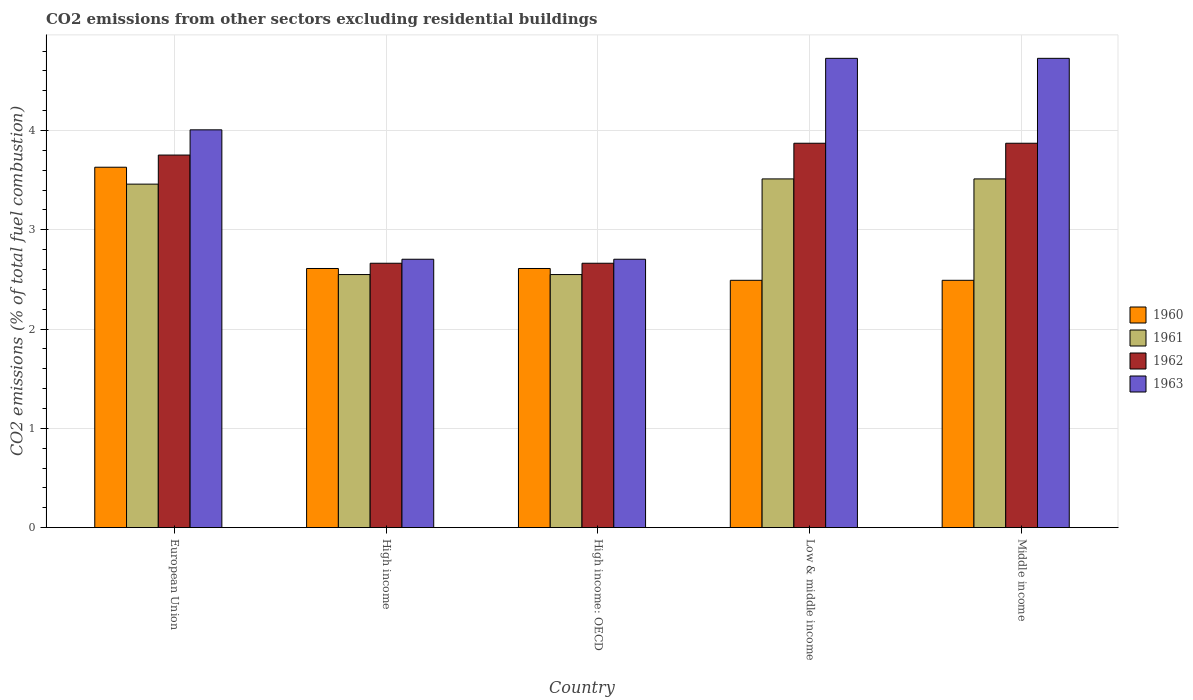How many different coloured bars are there?
Offer a terse response. 4. How many groups of bars are there?
Provide a short and direct response. 5. Are the number of bars per tick equal to the number of legend labels?
Offer a terse response. Yes. How many bars are there on the 3rd tick from the left?
Provide a succinct answer. 4. What is the total CO2 emitted in 1962 in European Union?
Provide a short and direct response. 3.75. Across all countries, what is the maximum total CO2 emitted in 1961?
Make the answer very short. 3.51. Across all countries, what is the minimum total CO2 emitted in 1961?
Provide a succinct answer. 2.55. What is the total total CO2 emitted in 1962 in the graph?
Offer a very short reply. 16.82. What is the difference between the total CO2 emitted in 1960 in High income and that in Low & middle income?
Ensure brevity in your answer.  0.12. What is the difference between the total CO2 emitted in 1961 in Middle income and the total CO2 emitted in 1960 in European Union?
Keep it short and to the point. -0.12. What is the average total CO2 emitted in 1961 per country?
Offer a terse response. 3.12. What is the difference between the total CO2 emitted of/in 1960 and total CO2 emitted of/in 1961 in Middle income?
Provide a short and direct response. -1.02. In how many countries, is the total CO2 emitted in 1960 greater than 1.2?
Offer a very short reply. 5. What is the ratio of the total CO2 emitted in 1961 in High income to that in Low & middle income?
Offer a very short reply. 0.73. Is the total CO2 emitted in 1961 in High income less than that in Low & middle income?
Your answer should be very brief. Yes. What is the difference between the highest and the second highest total CO2 emitted in 1963?
Provide a succinct answer. 0.72. What is the difference between the highest and the lowest total CO2 emitted in 1960?
Give a very brief answer. 1.14. What does the 2nd bar from the left in Middle income represents?
Offer a very short reply. 1961. What does the 4th bar from the right in European Union represents?
Provide a succinct answer. 1960. Is it the case that in every country, the sum of the total CO2 emitted in 1960 and total CO2 emitted in 1963 is greater than the total CO2 emitted in 1962?
Offer a very short reply. Yes. Are all the bars in the graph horizontal?
Ensure brevity in your answer.  No. How many countries are there in the graph?
Provide a succinct answer. 5. What is the difference between two consecutive major ticks on the Y-axis?
Make the answer very short. 1. Where does the legend appear in the graph?
Keep it short and to the point. Center right. How are the legend labels stacked?
Ensure brevity in your answer.  Vertical. What is the title of the graph?
Provide a short and direct response. CO2 emissions from other sectors excluding residential buildings. Does "1967" appear as one of the legend labels in the graph?
Keep it short and to the point. No. What is the label or title of the X-axis?
Your response must be concise. Country. What is the label or title of the Y-axis?
Ensure brevity in your answer.  CO2 emissions (% of total fuel combustion). What is the CO2 emissions (% of total fuel combustion) of 1960 in European Union?
Offer a very short reply. 3.63. What is the CO2 emissions (% of total fuel combustion) of 1961 in European Union?
Give a very brief answer. 3.46. What is the CO2 emissions (% of total fuel combustion) in 1962 in European Union?
Offer a very short reply. 3.75. What is the CO2 emissions (% of total fuel combustion) of 1963 in European Union?
Make the answer very short. 4.01. What is the CO2 emissions (% of total fuel combustion) in 1960 in High income?
Your response must be concise. 2.61. What is the CO2 emissions (% of total fuel combustion) in 1961 in High income?
Offer a very short reply. 2.55. What is the CO2 emissions (% of total fuel combustion) in 1962 in High income?
Your response must be concise. 2.66. What is the CO2 emissions (% of total fuel combustion) of 1963 in High income?
Your response must be concise. 2.7. What is the CO2 emissions (% of total fuel combustion) of 1960 in High income: OECD?
Provide a short and direct response. 2.61. What is the CO2 emissions (% of total fuel combustion) of 1961 in High income: OECD?
Provide a succinct answer. 2.55. What is the CO2 emissions (% of total fuel combustion) of 1962 in High income: OECD?
Give a very brief answer. 2.66. What is the CO2 emissions (% of total fuel combustion) in 1963 in High income: OECD?
Provide a short and direct response. 2.7. What is the CO2 emissions (% of total fuel combustion) of 1960 in Low & middle income?
Your response must be concise. 2.49. What is the CO2 emissions (% of total fuel combustion) in 1961 in Low & middle income?
Provide a succinct answer. 3.51. What is the CO2 emissions (% of total fuel combustion) of 1962 in Low & middle income?
Your answer should be compact. 3.87. What is the CO2 emissions (% of total fuel combustion) in 1963 in Low & middle income?
Give a very brief answer. 4.73. What is the CO2 emissions (% of total fuel combustion) in 1960 in Middle income?
Provide a succinct answer. 2.49. What is the CO2 emissions (% of total fuel combustion) in 1961 in Middle income?
Keep it short and to the point. 3.51. What is the CO2 emissions (% of total fuel combustion) of 1962 in Middle income?
Give a very brief answer. 3.87. What is the CO2 emissions (% of total fuel combustion) in 1963 in Middle income?
Give a very brief answer. 4.73. Across all countries, what is the maximum CO2 emissions (% of total fuel combustion) of 1960?
Your response must be concise. 3.63. Across all countries, what is the maximum CO2 emissions (% of total fuel combustion) of 1961?
Provide a succinct answer. 3.51. Across all countries, what is the maximum CO2 emissions (% of total fuel combustion) in 1962?
Provide a short and direct response. 3.87. Across all countries, what is the maximum CO2 emissions (% of total fuel combustion) in 1963?
Your response must be concise. 4.73. Across all countries, what is the minimum CO2 emissions (% of total fuel combustion) in 1960?
Offer a very short reply. 2.49. Across all countries, what is the minimum CO2 emissions (% of total fuel combustion) of 1961?
Your answer should be very brief. 2.55. Across all countries, what is the minimum CO2 emissions (% of total fuel combustion) in 1962?
Provide a succinct answer. 2.66. Across all countries, what is the minimum CO2 emissions (% of total fuel combustion) of 1963?
Offer a very short reply. 2.7. What is the total CO2 emissions (% of total fuel combustion) of 1960 in the graph?
Your response must be concise. 13.83. What is the total CO2 emissions (% of total fuel combustion) in 1961 in the graph?
Provide a succinct answer. 15.58. What is the total CO2 emissions (% of total fuel combustion) in 1962 in the graph?
Your response must be concise. 16.82. What is the total CO2 emissions (% of total fuel combustion) of 1963 in the graph?
Ensure brevity in your answer.  18.86. What is the difference between the CO2 emissions (% of total fuel combustion) in 1960 in European Union and that in High income?
Give a very brief answer. 1.02. What is the difference between the CO2 emissions (% of total fuel combustion) of 1961 in European Union and that in High income?
Offer a terse response. 0.91. What is the difference between the CO2 emissions (% of total fuel combustion) in 1962 in European Union and that in High income?
Provide a short and direct response. 1.09. What is the difference between the CO2 emissions (% of total fuel combustion) in 1963 in European Union and that in High income?
Offer a terse response. 1.3. What is the difference between the CO2 emissions (% of total fuel combustion) of 1960 in European Union and that in High income: OECD?
Make the answer very short. 1.02. What is the difference between the CO2 emissions (% of total fuel combustion) of 1961 in European Union and that in High income: OECD?
Offer a terse response. 0.91. What is the difference between the CO2 emissions (% of total fuel combustion) in 1962 in European Union and that in High income: OECD?
Your answer should be compact. 1.09. What is the difference between the CO2 emissions (% of total fuel combustion) of 1963 in European Union and that in High income: OECD?
Give a very brief answer. 1.3. What is the difference between the CO2 emissions (% of total fuel combustion) in 1960 in European Union and that in Low & middle income?
Your answer should be compact. 1.14. What is the difference between the CO2 emissions (% of total fuel combustion) in 1961 in European Union and that in Low & middle income?
Ensure brevity in your answer.  -0.05. What is the difference between the CO2 emissions (% of total fuel combustion) of 1962 in European Union and that in Low & middle income?
Offer a terse response. -0.12. What is the difference between the CO2 emissions (% of total fuel combustion) in 1963 in European Union and that in Low & middle income?
Provide a short and direct response. -0.72. What is the difference between the CO2 emissions (% of total fuel combustion) of 1960 in European Union and that in Middle income?
Your response must be concise. 1.14. What is the difference between the CO2 emissions (% of total fuel combustion) of 1961 in European Union and that in Middle income?
Provide a succinct answer. -0.05. What is the difference between the CO2 emissions (% of total fuel combustion) of 1962 in European Union and that in Middle income?
Your answer should be compact. -0.12. What is the difference between the CO2 emissions (% of total fuel combustion) in 1963 in European Union and that in Middle income?
Give a very brief answer. -0.72. What is the difference between the CO2 emissions (% of total fuel combustion) in 1960 in High income and that in High income: OECD?
Offer a terse response. 0. What is the difference between the CO2 emissions (% of total fuel combustion) of 1963 in High income and that in High income: OECD?
Offer a very short reply. 0. What is the difference between the CO2 emissions (% of total fuel combustion) of 1960 in High income and that in Low & middle income?
Keep it short and to the point. 0.12. What is the difference between the CO2 emissions (% of total fuel combustion) in 1961 in High income and that in Low & middle income?
Offer a very short reply. -0.96. What is the difference between the CO2 emissions (% of total fuel combustion) of 1962 in High income and that in Low & middle income?
Make the answer very short. -1.21. What is the difference between the CO2 emissions (% of total fuel combustion) of 1963 in High income and that in Low & middle income?
Make the answer very short. -2.02. What is the difference between the CO2 emissions (% of total fuel combustion) in 1960 in High income and that in Middle income?
Ensure brevity in your answer.  0.12. What is the difference between the CO2 emissions (% of total fuel combustion) in 1961 in High income and that in Middle income?
Make the answer very short. -0.96. What is the difference between the CO2 emissions (% of total fuel combustion) of 1962 in High income and that in Middle income?
Your answer should be compact. -1.21. What is the difference between the CO2 emissions (% of total fuel combustion) in 1963 in High income and that in Middle income?
Offer a very short reply. -2.02. What is the difference between the CO2 emissions (% of total fuel combustion) in 1960 in High income: OECD and that in Low & middle income?
Give a very brief answer. 0.12. What is the difference between the CO2 emissions (% of total fuel combustion) in 1961 in High income: OECD and that in Low & middle income?
Your answer should be compact. -0.96. What is the difference between the CO2 emissions (% of total fuel combustion) of 1962 in High income: OECD and that in Low & middle income?
Make the answer very short. -1.21. What is the difference between the CO2 emissions (% of total fuel combustion) of 1963 in High income: OECD and that in Low & middle income?
Offer a very short reply. -2.02. What is the difference between the CO2 emissions (% of total fuel combustion) of 1960 in High income: OECD and that in Middle income?
Provide a short and direct response. 0.12. What is the difference between the CO2 emissions (% of total fuel combustion) in 1961 in High income: OECD and that in Middle income?
Offer a very short reply. -0.96. What is the difference between the CO2 emissions (% of total fuel combustion) of 1962 in High income: OECD and that in Middle income?
Provide a short and direct response. -1.21. What is the difference between the CO2 emissions (% of total fuel combustion) of 1963 in High income: OECD and that in Middle income?
Keep it short and to the point. -2.02. What is the difference between the CO2 emissions (% of total fuel combustion) in 1960 in Low & middle income and that in Middle income?
Ensure brevity in your answer.  0. What is the difference between the CO2 emissions (% of total fuel combustion) of 1963 in Low & middle income and that in Middle income?
Provide a succinct answer. 0. What is the difference between the CO2 emissions (% of total fuel combustion) of 1960 in European Union and the CO2 emissions (% of total fuel combustion) of 1961 in High income?
Give a very brief answer. 1.08. What is the difference between the CO2 emissions (% of total fuel combustion) in 1960 in European Union and the CO2 emissions (% of total fuel combustion) in 1962 in High income?
Offer a terse response. 0.97. What is the difference between the CO2 emissions (% of total fuel combustion) of 1960 in European Union and the CO2 emissions (% of total fuel combustion) of 1963 in High income?
Offer a very short reply. 0.93. What is the difference between the CO2 emissions (% of total fuel combustion) in 1961 in European Union and the CO2 emissions (% of total fuel combustion) in 1962 in High income?
Offer a very short reply. 0.8. What is the difference between the CO2 emissions (% of total fuel combustion) of 1961 in European Union and the CO2 emissions (% of total fuel combustion) of 1963 in High income?
Ensure brevity in your answer.  0.76. What is the difference between the CO2 emissions (% of total fuel combustion) in 1962 in European Union and the CO2 emissions (% of total fuel combustion) in 1963 in High income?
Ensure brevity in your answer.  1.05. What is the difference between the CO2 emissions (% of total fuel combustion) of 1960 in European Union and the CO2 emissions (% of total fuel combustion) of 1961 in High income: OECD?
Make the answer very short. 1.08. What is the difference between the CO2 emissions (% of total fuel combustion) in 1960 in European Union and the CO2 emissions (% of total fuel combustion) in 1962 in High income: OECD?
Your response must be concise. 0.97. What is the difference between the CO2 emissions (% of total fuel combustion) of 1960 in European Union and the CO2 emissions (% of total fuel combustion) of 1963 in High income: OECD?
Ensure brevity in your answer.  0.93. What is the difference between the CO2 emissions (% of total fuel combustion) of 1961 in European Union and the CO2 emissions (% of total fuel combustion) of 1962 in High income: OECD?
Provide a short and direct response. 0.8. What is the difference between the CO2 emissions (% of total fuel combustion) of 1961 in European Union and the CO2 emissions (% of total fuel combustion) of 1963 in High income: OECD?
Your response must be concise. 0.76. What is the difference between the CO2 emissions (% of total fuel combustion) in 1962 in European Union and the CO2 emissions (% of total fuel combustion) in 1963 in High income: OECD?
Your answer should be compact. 1.05. What is the difference between the CO2 emissions (% of total fuel combustion) in 1960 in European Union and the CO2 emissions (% of total fuel combustion) in 1961 in Low & middle income?
Make the answer very short. 0.12. What is the difference between the CO2 emissions (% of total fuel combustion) of 1960 in European Union and the CO2 emissions (% of total fuel combustion) of 1962 in Low & middle income?
Your answer should be very brief. -0.24. What is the difference between the CO2 emissions (% of total fuel combustion) of 1960 in European Union and the CO2 emissions (% of total fuel combustion) of 1963 in Low & middle income?
Your response must be concise. -1.1. What is the difference between the CO2 emissions (% of total fuel combustion) in 1961 in European Union and the CO2 emissions (% of total fuel combustion) in 1962 in Low & middle income?
Offer a terse response. -0.41. What is the difference between the CO2 emissions (% of total fuel combustion) of 1961 in European Union and the CO2 emissions (% of total fuel combustion) of 1963 in Low & middle income?
Give a very brief answer. -1.27. What is the difference between the CO2 emissions (% of total fuel combustion) in 1962 in European Union and the CO2 emissions (% of total fuel combustion) in 1963 in Low & middle income?
Your answer should be compact. -0.97. What is the difference between the CO2 emissions (% of total fuel combustion) in 1960 in European Union and the CO2 emissions (% of total fuel combustion) in 1961 in Middle income?
Give a very brief answer. 0.12. What is the difference between the CO2 emissions (% of total fuel combustion) in 1960 in European Union and the CO2 emissions (% of total fuel combustion) in 1962 in Middle income?
Your response must be concise. -0.24. What is the difference between the CO2 emissions (% of total fuel combustion) of 1960 in European Union and the CO2 emissions (% of total fuel combustion) of 1963 in Middle income?
Make the answer very short. -1.1. What is the difference between the CO2 emissions (% of total fuel combustion) of 1961 in European Union and the CO2 emissions (% of total fuel combustion) of 1962 in Middle income?
Make the answer very short. -0.41. What is the difference between the CO2 emissions (% of total fuel combustion) of 1961 in European Union and the CO2 emissions (% of total fuel combustion) of 1963 in Middle income?
Keep it short and to the point. -1.27. What is the difference between the CO2 emissions (% of total fuel combustion) of 1962 in European Union and the CO2 emissions (% of total fuel combustion) of 1963 in Middle income?
Keep it short and to the point. -0.97. What is the difference between the CO2 emissions (% of total fuel combustion) of 1960 in High income and the CO2 emissions (% of total fuel combustion) of 1961 in High income: OECD?
Offer a very short reply. 0.06. What is the difference between the CO2 emissions (% of total fuel combustion) in 1960 in High income and the CO2 emissions (% of total fuel combustion) in 1962 in High income: OECD?
Give a very brief answer. -0.05. What is the difference between the CO2 emissions (% of total fuel combustion) in 1960 in High income and the CO2 emissions (% of total fuel combustion) in 1963 in High income: OECD?
Make the answer very short. -0.09. What is the difference between the CO2 emissions (% of total fuel combustion) in 1961 in High income and the CO2 emissions (% of total fuel combustion) in 1962 in High income: OECD?
Make the answer very short. -0.11. What is the difference between the CO2 emissions (% of total fuel combustion) in 1961 in High income and the CO2 emissions (% of total fuel combustion) in 1963 in High income: OECD?
Offer a terse response. -0.15. What is the difference between the CO2 emissions (% of total fuel combustion) of 1962 in High income and the CO2 emissions (% of total fuel combustion) of 1963 in High income: OECD?
Give a very brief answer. -0.04. What is the difference between the CO2 emissions (% of total fuel combustion) in 1960 in High income and the CO2 emissions (% of total fuel combustion) in 1961 in Low & middle income?
Your answer should be very brief. -0.9. What is the difference between the CO2 emissions (% of total fuel combustion) of 1960 in High income and the CO2 emissions (% of total fuel combustion) of 1962 in Low & middle income?
Provide a succinct answer. -1.26. What is the difference between the CO2 emissions (% of total fuel combustion) of 1960 in High income and the CO2 emissions (% of total fuel combustion) of 1963 in Low & middle income?
Your answer should be compact. -2.12. What is the difference between the CO2 emissions (% of total fuel combustion) in 1961 in High income and the CO2 emissions (% of total fuel combustion) in 1962 in Low & middle income?
Make the answer very short. -1.32. What is the difference between the CO2 emissions (% of total fuel combustion) in 1961 in High income and the CO2 emissions (% of total fuel combustion) in 1963 in Low & middle income?
Your answer should be very brief. -2.18. What is the difference between the CO2 emissions (% of total fuel combustion) of 1962 in High income and the CO2 emissions (% of total fuel combustion) of 1963 in Low & middle income?
Ensure brevity in your answer.  -2.06. What is the difference between the CO2 emissions (% of total fuel combustion) in 1960 in High income and the CO2 emissions (% of total fuel combustion) in 1961 in Middle income?
Ensure brevity in your answer.  -0.9. What is the difference between the CO2 emissions (% of total fuel combustion) in 1960 in High income and the CO2 emissions (% of total fuel combustion) in 1962 in Middle income?
Offer a terse response. -1.26. What is the difference between the CO2 emissions (% of total fuel combustion) in 1960 in High income and the CO2 emissions (% of total fuel combustion) in 1963 in Middle income?
Keep it short and to the point. -2.12. What is the difference between the CO2 emissions (% of total fuel combustion) in 1961 in High income and the CO2 emissions (% of total fuel combustion) in 1962 in Middle income?
Your answer should be very brief. -1.32. What is the difference between the CO2 emissions (% of total fuel combustion) in 1961 in High income and the CO2 emissions (% of total fuel combustion) in 1963 in Middle income?
Make the answer very short. -2.18. What is the difference between the CO2 emissions (% of total fuel combustion) of 1962 in High income and the CO2 emissions (% of total fuel combustion) of 1963 in Middle income?
Give a very brief answer. -2.06. What is the difference between the CO2 emissions (% of total fuel combustion) in 1960 in High income: OECD and the CO2 emissions (% of total fuel combustion) in 1961 in Low & middle income?
Your answer should be compact. -0.9. What is the difference between the CO2 emissions (% of total fuel combustion) in 1960 in High income: OECD and the CO2 emissions (% of total fuel combustion) in 1962 in Low & middle income?
Your response must be concise. -1.26. What is the difference between the CO2 emissions (% of total fuel combustion) in 1960 in High income: OECD and the CO2 emissions (% of total fuel combustion) in 1963 in Low & middle income?
Provide a succinct answer. -2.12. What is the difference between the CO2 emissions (% of total fuel combustion) of 1961 in High income: OECD and the CO2 emissions (% of total fuel combustion) of 1962 in Low & middle income?
Ensure brevity in your answer.  -1.32. What is the difference between the CO2 emissions (% of total fuel combustion) in 1961 in High income: OECD and the CO2 emissions (% of total fuel combustion) in 1963 in Low & middle income?
Ensure brevity in your answer.  -2.18. What is the difference between the CO2 emissions (% of total fuel combustion) in 1962 in High income: OECD and the CO2 emissions (% of total fuel combustion) in 1963 in Low & middle income?
Ensure brevity in your answer.  -2.06. What is the difference between the CO2 emissions (% of total fuel combustion) in 1960 in High income: OECD and the CO2 emissions (% of total fuel combustion) in 1961 in Middle income?
Offer a very short reply. -0.9. What is the difference between the CO2 emissions (% of total fuel combustion) in 1960 in High income: OECD and the CO2 emissions (% of total fuel combustion) in 1962 in Middle income?
Keep it short and to the point. -1.26. What is the difference between the CO2 emissions (% of total fuel combustion) in 1960 in High income: OECD and the CO2 emissions (% of total fuel combustion) in 1963 in Middle income?
Offer a terse response. -2.12. What is the difference between the CO2 emissions (% of total fuel combustion) of 1961 in High income: OECD and the CO2 emissions (% of total fuel combustion) of 1962 in Middle income?
Your answer should be compact. -1.32. What is the difference between the CO2 emissions (% of total fuel combustion) of 1961 in High income: OECD and the CO2 emissions (% of total fuel combustion) of 1963 in Middle income?
Your answer should be very brief. -2.18. What is the difference between the CO2 emissions (% of total fuel combustion) in 1962 in High income: OECD and the CO2 emissions (% of total fuel combustion) in 1963 in Middle income?
Your answer should be very brief. -2.06. What is the difference between the CO2 emissions (% of total fuel combustion) of 1960 in Low & middle income and the CO2 emissions (% of total fuel combustion) of 1961 in Middle income?
Your answer should be very brief. -1.02. What is the difference between the CO2 emissions (% of total fuel combustion) of 1960 in Low & middle income and the CO2 emissions (% of total fuel combustion) of 1962 in Middle income?
Offer a very short reply. -1.38. What is the difference between the CO2 emissions (% of total fuel combustion) of 1960 in Low & middle income and the CO2 emissions (% of total fuel combustion) of 1963 in Middle income?
Offer a terse response. -2.24. What is the difference between the CO2 emissions (% of total fuel combustion) in 1961 in Low & middle income and the CO2 emissions (% of total fuel combustion) in 1962 in Middle income?
Your response must be concise. -0.36. What is the difference between the CO2 emissions (% of total fuel combustion) in 1961 in Low & middle income and the CO2 emissions (% of total fuel combustion) in 1963 in Middle income?
Your answer should be compact. -1.21. What is the difference between the CO2 emissions (% of total fuel combustion) in 1962 in Low & middle income and the CO2 emissions (% of total fuel combustion) in 1963 in Middle income?
Make the answer very short. -0.85. What is the average CO2 emissions (% of total fuel combustion) of 1960 per country?
Keep it short and to the point. 2.77. What is the average CO2 emissions (% of total fuel combustion) of 1961 per country?
Your answer should be compact. 3.12. What is the average CO2 emissions (% of total fuel combustion) in 1962 per country?
Provide a short and direct response. 3.36. What is the average CO2 emissions (% of total fuel combustion) in 1963 per country?
Offer a very short reply. 3.77. What is the difference between the CO2 emissions (% of total fuel combustion) in 1960 and CO2 emissions (% of total fuel combustion) in 1961 in European Union?
Your response must be concise. 0.17. What is the difference between the CO2 emissions (% of total fuel combustion) in 1960 and CO2 emissions (% of total fuel combustion) in 1962 in European Union?
Keep it short and to the point. -0.12. What is the difference between the CO2 emissions (% of total fuel combustion) of 1960 and CO2 emissions (% of total fuel combustion) of 1963 in European Union?
Your answer should be compact. -0.38. What is the difference between the CO2 emissions (% of total fuel combustion) in 1961 and CO2 emissions (% of total fuel combustion) in 1962 in European Union?
Make the answer very short. -0.29. What is the difference between the CO2 emissions (% of total fuel combustion) in 1961 and CO2 emissions (% of total fuel combustion) in 1963 in European Union?
Offer a very short reply. -0.55. What is the difference between the CO2 emissions (% of total fuel combustion) of 1962 and CO2 emissions (% of total fuel combustion) of 1963 in European Union?
Provide a short and direct response. -0.25. What is the difference between the CO2 emissions (% of total fuel combustion) in 1960 and CO2 emissions (% of total fuel combustion) in 1961 in High income?
Keep it short and to the point. 0.06. What is the difference between the CO2 emissions (% of total fuel combustion) of 1960 and CO2 emissions (% of total fuel combustion) of 1962 in High income?
Keep it short and to the point. -0.05. What is the difference between the CO2 emissions (% of total fuel combustion) of 1960 and CO2 emissions (% of total fuel combustion) of 1963 in High income?
Ensure brevity in your answer.  -0.09. What is the difference between the CO2 emissions (% of total fuel combustion) of 1961 and CO2 emissions (% of total fuel combustion) of 1962 in High income?
Provide a succinct answer. -0.11. What is the difference between the CO2 emissions (% of total fuel combustion) of 1961 and CO2 emissions (% of total fuel combustion) of 1963 in High income?
Your answer should be compact. -0.15. What is the difference between the CO2 emissions (% of total fuel combustion) in 1962 and CO2 emissions (% of total fuel combustion) in 1963 in High income?
Your response must be concise. -0.04. What is the difference between the CO2 emissions (% of total fuel combustion) in 1960 and CO2 emissions (% of total fuel combustion) in 1961 in High income: OECD?
Keep it short and to the point. 0.06. What is the difference between the CO2 emissions (% of total fuel combustion) in 1960 and CO2 emissions (% of total fuel combustion) in 1962 in High income: OECD?
Your answer should be very brief. -0.05. What is the difference between the CO2 emissions (% of total fuel combustion) of 1960 and CO2 emissions (% of total fuel combustion) of 1963 in High income: OECD?
Keep it short and to the point. -0.09. What is the difference between the CO2 emissions (% of total fuel combustion) in 1961 and CO2 emissions (% of total fuel combustion) in 1962 in High income: OECD?
Ensure brevity in your answer.  -0.11. What is the difference between the CO2 emissions (% of total fuel combustion) of 1961 and CO2 emissions (% of total fuel combustion) of 1963 in High income: OECD?
Make the answer very short. -0.15. What is the difference between the CO2 emissions (% of total fuel combustion) of 1962 and CO2 emissions (% of total fuel combustion) of 1963 in High income: OECD?
Your response must be concise. -0.04. What is the difference between the CO2 emissions (% of total fuel combustion) in 1960 and CO2 emissions (% of total fuel combustion) in 1961 in Low & middle income?
Provide a short and direct response. -1.02. What is the difference between the CO2 emissions (% of total fuel combustion) in 1960 and CO2 emissions (% of total fuel combustion) in 1962 in Low & middle income?
Your answer should be very brief. -1.38. What is the difference between the CO2 emissions (% of total fuel combustion) in 1960 and CO2 emissions (% of total fuel combustion) in 1963 in Low & middle income?
Offer a very short reply. -2.24. What is the difference between the CO2 emissions (% of total fuel combustion) of 1961 and CO2 emissions (% of total fuel combustion) of 1962 in Low & middle income?
Offer a terse response. -0.36. What is the difference between the CO2 emissions (% of total fuel combustion) of 1961 and CO2 emissions (% of total fuel combustion) of 1963 in Low & middle income?
Give a very brief answer. -1.21. What is the difference between the CO2 emissions (% of total fuel combustion) in 1962 and CO2 emissions (% of total fuel combustion) in 1963 in Low & middle income?
Offer a terse response. -0.85. What is the difference between the CO2 emissions (% of total fuel combustion) of 1960 and CO2 emissions (% of total fuel combustion) of 1961 in Middle income?
Offer a very short reply. -1.02. What is the difference between the CO2 emissions (% of total fuel combustion) of 1960 and CO2 emissions (% of total fuel combustion) of 1962 in Middle income?
Offer a very short reply. -1.38. What is the difference between the CO2 emissions (% of total fuel combustion) of 1960 and CO2 emissions (% of total fuel combustion) of 1963 in Middle income?
Offer a very short reply. -2.24. What is the difference between the CO2 emissions (% of total fuel combustion) in 1961 and CO2 emissions (% of total fuel combustion) in 1962 in Middle income?
Provide a short and direct response. -0.36. What is the difference between the CO2 emissions (% of total fuel combustion) in 1961 and CO2 emissions (% of total fuel combustion) in 1963 in Middle income?
Offer a terse response. -1.21. What is the difference between the CO2 emissions (% of total fuel combustion) of 1962 and CO2 emissions (% of total fuel combustion) of 1963 in Middle income?
Ensure brevity in your answer.  -0.85. What is the ratio of the CO2 emissions (% of total fuel combustion) of 1960 in European Union to that in High income?
Your response must be concise. 1.39. What is the ratio of the CO2 emissions (% of total fuel combustion) of 1961 in European Union to that in High income?
Offer a terse response. 1.36. What is the ratio of the CO2 emissions (% of total fuel combustion) of 1962 in European Union to that in High income?
Your response must be concise. 1.41. What is the ratio of the CO2 emissions (% of total fuel combustion) in 1963 in European Union to that in High income?
Make the answer very short. 1.48. What is the ratio of the CO2 emissions (% of total fuel combustion) in 1960 in European Union to that in High income: OECD?
Ensure brevity in your answer.  1.39. What is the ratio of the CO2 emissions (% of total fuel combustion) in 1961 in European Union to that in High income: OECD?
Keep it short and to the point. 1.36. What is the ratio of the CO2 emissions (% of total fuel combustion) in 1962 in European Union to that in High income: OECD?
Provide a succinct answer. 1.41. What is the ratio of the CO2 emissions (% of total fuel combustion) of 1963 in European Union to that in High income: OECD?
Give a very brief answer. 1.48. What is the ratio of the CO2 emissions (% of total fuel combustion) in 1960 in European Union to that in Low & middle income?
Your answer should be compact. 1.46. What is the ratio of the CO2 emissions (% of total fuel combustion) in 1961 in European Union to that in Low & middle income?
Provide a succinct answer. 0.98. What is the ratio of the CO2 emissions (% of total fuel combustion) in 1962 in European Union to that in Low & middle income?
Offer a very short reply. 0.97. What is the ratio of the CO2 emissions (% of total fuel combustion) of 1963 in European Union to that in Low & middle income?
Provide a succinct answer. 0.85. What is the ratio of the CO2 emissions (% of total fuel combustion) of 1960 in European Union to that in Middle income?
Provide a succinct answer. 1.46. What is the ratio of the CO2 emissions (% of total fuel combustion) in 1961 in European Union to that in Middle income?
Make the answer very short. 0.98. What is the ratio of the CO2 emissions (% of total fuel combustion) in 1962 in European Union to that in Middle income?
Your answer should be very brief. 0.97. What is the ratio of the CO2 emissions (% of total fuel combustion) of 1963 in European Union to that in Middle income?
Give a very brief answer. 0.85. What is the ratio of the CO2 emissions (% of total fuel combustion) of 1960 in High income to that in Low & middle income?
Your answer should be compact. 1.05. What is the ratio of the CO2 emissions (% of total fuel combustion) of 1961 in High income to that in Low & middle income?
Your answer should be compact. 0.73. What is the ratio of the CO2 emissions (% of total fuel combustion) in 1962 in High income to that in Low & middle income?
Provide a succinct answer. 0.69. What is the ratio of the CO2 emissions (% of total fuel combustion) of 1963 in High income to that in Low & middle income?
Provide a succinct answer. 0.57. What is the ratio of the CO2 emissions (% of total fuel combustion) in 1960 in High income to that in Middle income?
Your response must be concise. 1.05. What is the ratio of the CO2 emissions (% of total fuel combustion) in 1961 in High income to that in Middle income?
Your answer should be very brief. 0.73. What is the ratio of the CO2 emissions (% of total fuel combustion) in 1962 in High income to that in Middle income?
Offer a very short reply. 0.69. What is the ratio of the CO2 emissions (% of total fuel combustion) of 1963 in High income to that in Middle income?
Your answer should be compact. 0.57. What is the ratio of the CO2 emissions (% of total fuel combustion) in 1960 in High income: OECD to that in Low & middle income?
Offer a terse response. 1.05. What is the ratio of the CO2 emissions (% of total fuel combustion) in 1961 in High income: OECD to that in Low & middle income?
Your answer should be very brief. 0.73. What is the ratio of the CO2 emissions (% of total fuel combustion) in 1962 in High income: OECD to that in Low & middle income?
Keep it short and to the point. 0.69. What is the ratio of the CO2 emissions (% of total fuel combustion) of 1963 in High income: OECD to that in Low & middle income?
Your response must be concise. 0.57. What is the ratio of the CO2 emissions (% of total fuel combustion) of 1960 in High income: OECD to that in Middle income?
Ensure brevity in your answer.  1.05. What is the ratio of the CO2 emissions (% of total fuel combustion) in 1961 in High income: OECD to that in Middle income?
Keep it short and to the point. 0.73. What is the ratio of the CO2 emissions (% of total fuel combustion) of 1962 in High income: OECD to that in Middle income?
Your answer should be very brief. 0.69. What is the ratio of the CO2 emissions (% of total fuel combustion) of 1963 in High income: OECD to that in Middle income?
Your answer should be compact. 0.57. What is the ratio of the CO2 emissions (% of total fuel combustion) of 1960 in Low & middle income to that in Middle income?
Provide a short and direct response. 1. What is the ratio of the CO2 emissions (% of total fuel combustion) of 1961 in Low & middle income to that in Middle income?
Keep it short and to the point. 1. What is the ratio of the CO2 emissions (% of total fuel combustion) of 1963 in Low & middle income to that in Middle income?
Provide a succinct answer. 1. What is the difference between the highest and the second highest CO2 emissions (% of total fuel combustion) in 1961?
Provide a short and direct response. 0. What is the difference between the highest and the second highest CO2 emissions (% of total fuel combustion) in 1962?
Make the answer very short. 0. What is the difference between the highest and the second highest CO2 emissions (% of total fuel combustion) in 1963?
Offer a terse response. 0. What is the difference between the highest and the lowest CO2 emissions (% of total fuel combustion) of 1960?
Make the answer very short. 1.14. What is the difference between the highest and the lowest CO2 emissions (% of total fuel combustion) of 1961?
Ensure brevity in your answer.  0.96. What is the difference between the highest and the lowest CO2 emissions (% of total fuel combustion) of 1962?
Give a very brief answer. 1.21. What is the difference between the highest and the lowest CO2 emissions (% of total fuel combustion) in 1963?
Offer a very short reply. 2.02. 